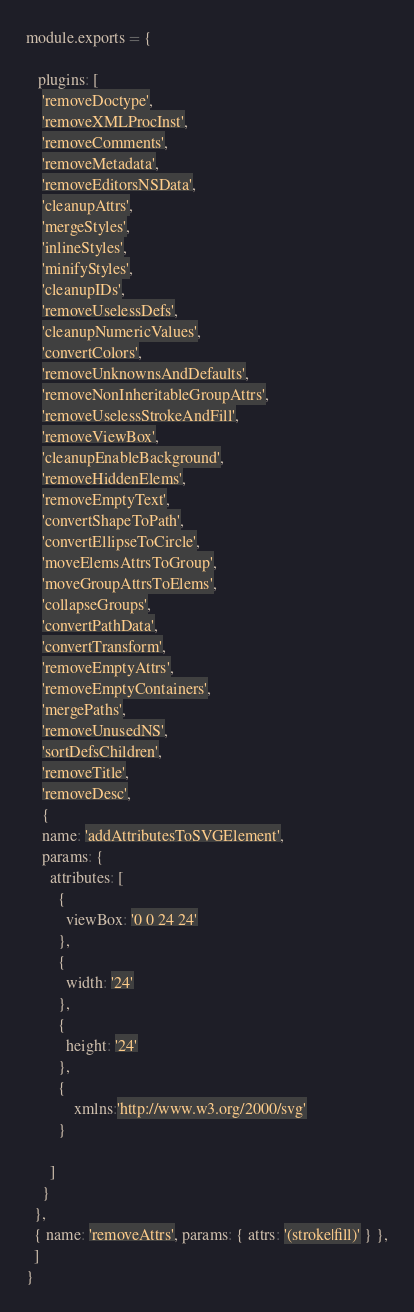Convert code to text. <code><loc_0><loc_0><loc_500><loc_500><_JavaScript_>module.exports = {
	
   plugins: [
    'removeDoctype',
    'removeXMLProcInst',
    'removeComments',
    'removeMetadata',
    'removeEditorsNSData',
    'cleanupAttrs',
    'mergeStyles',
    'inlineStyles',
    'minifyStyles',
    'cleanupIDs',
    'removeUselessDefs',
    'cleanupNumericValues',
    'convertColors',
    'removeUnknownsAndDefaults',
    'removeNonInheritableGroupAttrs',
    'removeUselessStrokeAndFill',
    'removeViewBox',
    'cleanupEnableBackground',
    'removeHiddenElems',
    'removeEmptyText',
    'convertShapeToPath',
    'convertEllipseToCircle',
    'moveElemsAttrsToGroup',
    'moveGroupAttrsToElems',
    'collapseGroups',
    'convertPathData',
    'convertTransform',
    'removeEmptyAttrs',
    'removeEmptyContainers',
    'mergePaths',
    'removeUnusedNS',
    'sortDefsChildren',
    'removeTitle',
    'removeDesc',
	{
    name: 'addAttributesToSVGElement',
    params: {
      attributes: [
        {
          viewBox: '0 0 24 24'
        },
		{
          width: '24'
        },
		{
          height: '24'
        },
		{
			xmlns:'http://www.w3.org/2000/svg'
		}
		
      ]
    }
  },
  { name: 'removeAttrs', params: { attrs: '(stroke|fill)' } },
  ]
}</code> 